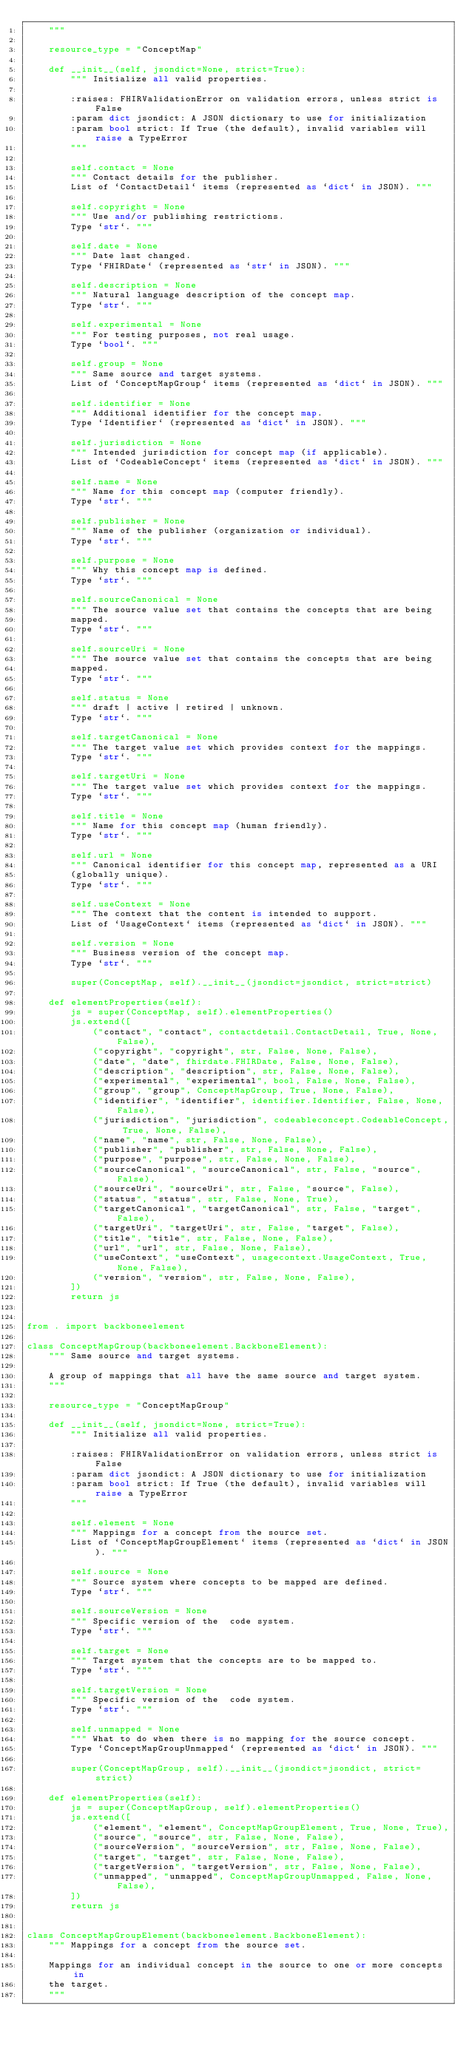Convert code to text. <code><loc_0><loc_0><loc_500><loc_500><_Python_>    """
    
    resource_type = "ConceptMap"
    
    def __init__(self, jsondict=None, strict=True):
        """ Initialize all valid properties.
        
        :raises: FHIRValidationError on validation errors, unless strict is False
        :param dict jsondict: A JSON dictionary to use for initialization
        :param bool strict: If True (the default), invalid variables will raise a TypeError
        """
        
        self.contact = None
        """ Contact details for the publisher.
        List of `ContactDetail` items (represented as `dict` in JSON). """
        
        self.copyright = None
        """ Use and/or publishing restrictions.
        Type `str`. """
        
        self.date = None
        """ Date last changed.
        Type `FHIRDate` (represented as `str` in JSON). """
        
        self.description = None
        """ Natural language description of the concept map.
        Type `str`. """
        
        self.experimental = None
        """ For testing purposes, not real usage.
        Type `bool`. """
        
        self.group = None
        """ Same source and target systems.
        List of `ConceptMapGroup` items (represented as `dict` in JSON). """
        
        self.identifier = None
        """ Additional identifier for the concept map.
        Type `Identifier` (represented as `dict` in JSON). """
        
        self.jurisdiction = None
        """ Intended jurisdiction for concept map (if applicable).
        List of `CodeableConcept` items (represented as `dict` in JSON). """
        
        self.name = None
        """ Name for this concept map (computer friendly).
        Type `str`. """
        
        self.publisher = None
        """ Name of the publisher (organization or individual).
        Type `str`. """
        
        self.purpose = None
        """ Why this concept map is defined.
        Type `str`. """
        
        self.sourceCanonical = None
        """ The source value set that contains the concepts that are being
        mapped.
        Type `str`. """
        
        self.sourceUri = None
        """ The source value set that contains the concepts that are being
        mapped.
        Type `str`. """
        
        self.status = None
        """ draft | active | retired | unknown.
        Type `str`. """
        
        self.targetCanonical = None
        """ The target value set which provides context for the mappings.
        Type `str`. """
        
        self.targetUri = None
        """ The target value set which provides context for the mappings.
        Type `str`. """
        
        self.title = None
        """ Name for this concept map (human friendly).
        Type `str`. """
        
        self.url = None
        """ Canonical identifier for this concept map, represented as a URI
        (globally unique).
        Type `str`. """
        
        self.useContext = None
        """ The context that the content is intended to support.
        List of `UsageContext` items (represented as `dict` in JSON). """
        
        self.version = None
        """ Business version of the concept map.
        Type `str`. """
        
        super(ConceptMap, self).__init__(jsondict=jsondict, strict=strict)
    
    def elementProperties(self):
        js = super(ConceptMap, self).elementProperties()
        js.extend([
            ("contact", "contact", contactdetail.ContactDetail, True, None, False),
            ("copyright", "copyright", str, False, None, False),
            ("date", "date", fhirdate.FHIRDate, False, None, False),
            ("description", "description", str, False, None, False),
            ("experimental", "experimental", bool, False, None, False),
            ("group", "group", ConceptMapGroup, True, None, False),
            ("identifier", "identifier", identifier.Identifier, False, None, False),
            ("jurisdiction", "jurisdiction", codeableconcept.CodeableConcept, True, None, False),
            ("name", "name", str, False, None, False),
            ("publisher", "publisher", str, False, None, False),
            ("purpose", "purpose", str, False, None, False),
            ("sourceCanonical", "sourceCanonical", str, False, "source", False),
            ("sourceUri", "sourceUri", str, False, "source", False),
            ("status", "status", str, False, None, True),
            ("targetCanonical", "targetCanonical", str, False, "target", False),
            ("targetUri", "targetUri", str, False, "target", False),
            ("title", "title", str, False, None, False),
            ("url", "url", str, False, None, False),
            ("useContext", "useContext", usagecontext.UsageContext, True, None, False),
            ("version", "version", str, False, None, False),
        ])
        return js


from . import backboneelement

class ConceptMapGroup(backboneelement.BackboneElement):
    """ Same source and target systems.
    
    A group of mappings that all have the same source and target system.
    """
    
    resource_type = "ConceptMapGroup"
    
    def __init__(self, jsondict=None, strict=True):
        """ Initialize all valid properties.
        
        :raises: FHIRValidationError on validation errors, unless strict is False
        :param dict jsondict: A JSON dictionary to use for initialization
        :param bool strict: If True (the default), invalid variables will raise a TypeError
        """
        
        self.element = None
        """ Mappings for a concept from the source set.
        List of `ConceptMapGroupElement` items (represented as `dict` in JSON). """
        
        self.source = None
        """ Source system where concepts to be mapped are defined.
        Type `str`. """
        
        self.sourceVersion = None
        """ Specific version of the  code system.
        Type `str`. """
        
        self.target = None
        """ Target system that the concepts are to be mapped to.
        Type `str`. """
        
        self.targetVersion = None
        """ Specific version of the  code system.
        Type `str`. """
        
        self.unmapped = None
        """ What to do when there is no mapping for the source concept.
        Type `ConceptMapGroupUnmapped` (represented as `dict` in JSON). """
        
        super(ConceptMapGroup, self).__init__(jsondict=jsondict, strict=strict)
    
    def elementProperties(self):
        js = super(ConceptMapGroup, self).elementProperties()
        js.extend([
            ("element", "element", ConceptMapGroupElement, True, None, True),
            ("source", "source", str, False, None, False),
            ("sourceVersion", "sourceVersion", str, False, None, False),
            ("target", "target", str, False, None, False),
            ("targetVersion", "targetVersion", str, False, None, False),
            ("unmapped", "unmapped", ConceptMapGroupUnmapped, False, None, False),
        ])
        return js


class ConceptMapGroupElement(backboneelement.BackboneElement):
    """ Mappings for a concept from the source set.
    
    Mappings for an individual concept in the source to one or more concepts in
    the target.
    """
    </code> 